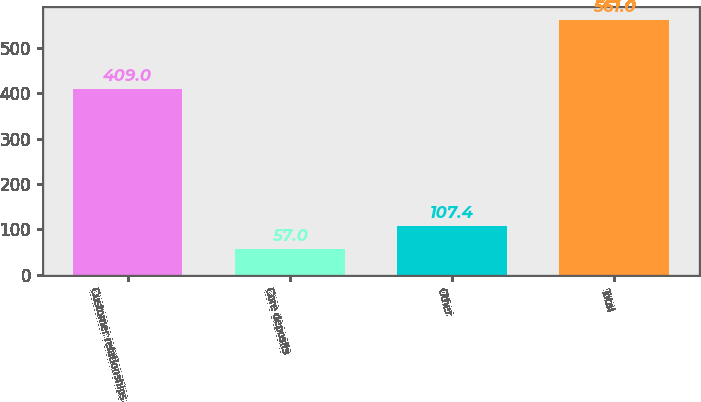Convert chart to OTSL. <chart><loc_0><loc_0><loc_500><loc_500><bar_chart><fcel>Customer relationships<fcel>Core deposits<fcel>Other<fcel>Total<nl><fcel>409<fcel>57<fcel>107.4<fcel>561<nl></chart> 